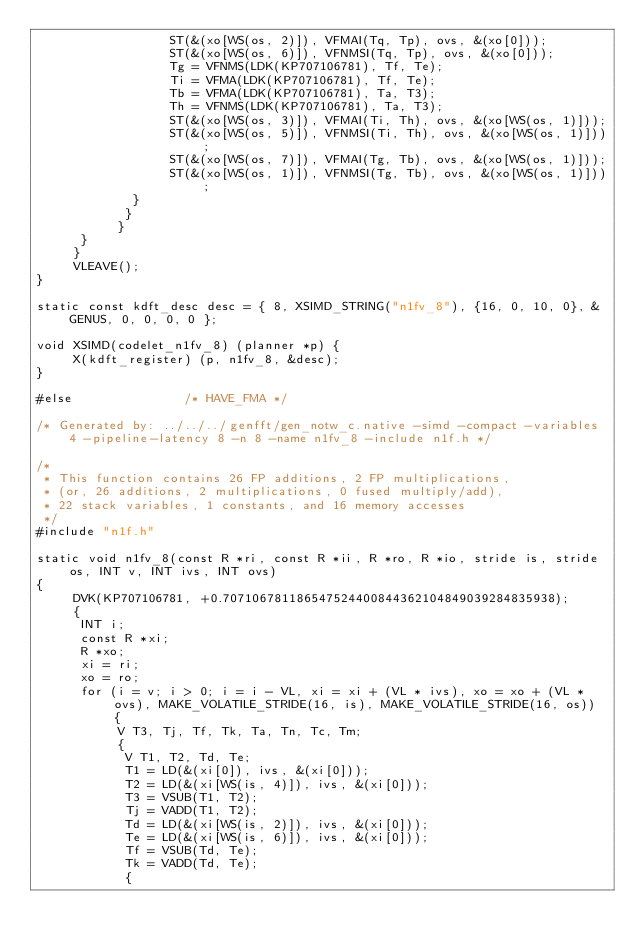Convert code to text. <code><loc_0><loc_0><loc_500><loc_500><_C_>			      ST(&(xo[WS(os, 2)]), VFMAI(Tq, Tp), ovs, &(xo[0]));
			      ST(&(xo[WS(os, 6)]), VFNMSI(Tq, Tp), ovs, &(xo[0]));
			      Tg = VFNMS(LDK(KP707106781), Tf, Te);
			      Ti = VFMA(LDK(KP707106781), Tf, Te);
			      Tb = VFMA(LDK(KP707106781), Ta, T3);
			      Th = VFNMS(LDK(KP707106781), Ta, T3);
			      ST(&(xo[WS(os, 3)]), VFMAI(Ti, Th), ovs, &(xo[WS(os, 1)]));
			      ST(&(xo[WS(os, 5)]), VFNMSI(Ti, Th), ovs, &(xo[WS(os, 1)]));
			      ST(&(xo[WS(os, 7)]), VFMAI(Tg, Tb), ovs, &(xo[WS(os, 1)]));
			      ST(&(xo[WS(os, 1)]), VFNMSI(Tg, Tb), ovs, &(xo[WS(os, 1)]));
			 }
		    }
	       }
	  }
     }
     VLEAVE();
}

static const kdft_desc desc = { 8, XSIMD_STRING("n1fv_8"), {16, 0, 10, 0}, &GENUS, 0, 0, 0, 0 };

void XSIMD(codelet_n1fv_8) (planner *p) {
     X(kdft_register) (p, n1fv_8, &desc);
}

#else				/* HAVE_FMA */

/* Generated by: ../../../genfft/gen_notw_c.native -simd -compact -variables 4 -pipeline-latency 8 -n 8 -name n1fv_8 -include n1f.h */

/*
 * This function contains 26 FP additions, 2 FP multiplications,
 * (or, 26 additions, 2 multiplications, 0 fused multiply/add),
 * 22 stack variables, 1 constants, and 16 memory accesses
 */
#include "n1f.h"

static void n1fv_8(const R *ri, const R *ii, R *ro, R *io, stride is, stride os, INT v, INT ivs, INT ovs)
{
     DVK(KP707106781, +0.707106781186547524400844362104849039284835938);
     {
	  INT i;
	  const R *xi;
	  R *xo;
	  xi = ri;
	  xo = ro;
	  for (i = v; i > 0; i = i - VL, xi = xi + (VL * ivs), xo = xo + (VL * ovs), MAKE_VOLATILE_STRIDE(16, is), MAKE_VOLATILE_STRIDE(16, os)) {
	       V T3, Tj, Tf, Tk, Ta, Tn, Tc, Tm;
	       {
		    V T1, T2, Td, Te;
		    T1 = LD(&(xi[0]), ivs, &(xi[0]));
		    T2 = LD(&(xi[WS(is, 4)]), ivs, &(xi[0]));
		    T3 = VSUB(T1, T2);
		    Tj = VADD(T1, T2);
		    Td = LD(&(xi[WS(is, 2)]), ivs, &(xi[0]));
		    Te = LD(&(xi[WS(is, 6)]), ivs, &(xi[0]));
		    Tf = VSUB(Td, Te);
		    Tk = VADD(Td, Te);
		    {</code> 